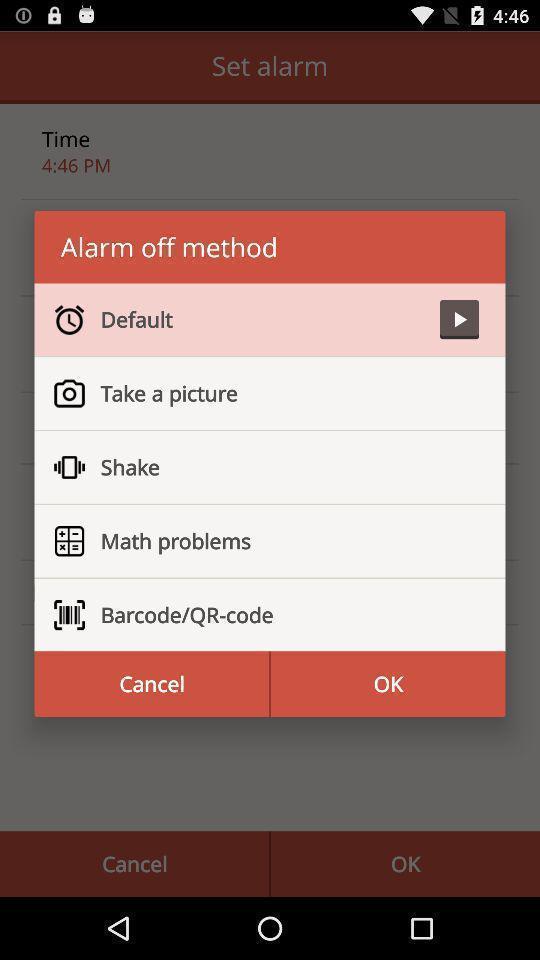What details can you identify in this image? Popup displaying list of alarm of method. 